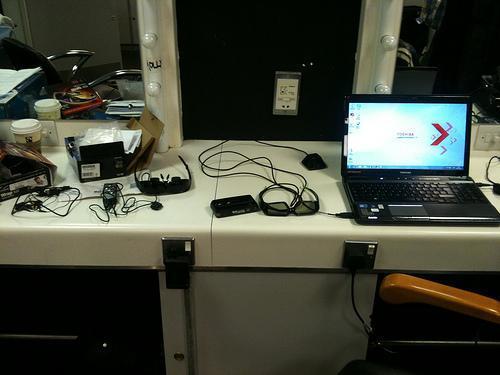How many computer are there?
Give a very brief answer. 1. How many cables are connected to the laptop?
Give a very brief answer. 2. 